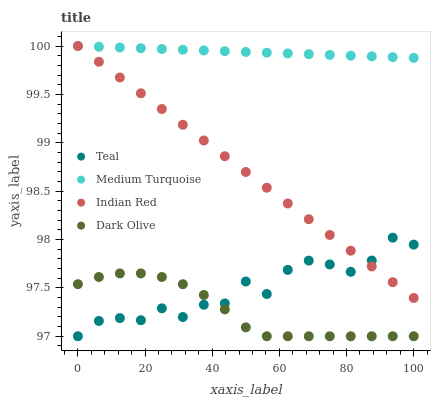Does Dark Olive have the minimum area under the curve?
Answer yes or no. Yes. Does Medium Turquoise have the maximum area under the curve?
Answer yes or no. Yes. Does Medium Turquoise have the minimum area under the curve?
Answer yes or no. No. Does Dark Olive have the maximum area under the curve?
Answer yes or no. No. Is Medium Turquoise the smoothest?
Answer yes or no. Yes. Is Teal the roughest?
Answer yes or no. Yes. Is Dark Olive the smoothest?
Answer yes or no. No. Is Dark Olive the roughest?
Answer yes or no. No. Does Dark Olive have the lowest value?
Answer yes or no. Yes. Does Medium Turquoise have the lowest value?
Answer yes or no. No. Does Medium Turquoise have the highest value?
Answer yes or no. Yes. Does Dark Olive have the highest value?
Answer yes or no. No. Is Teal less than Medium Turquoise?
Answer yes or no. Yes. Is Medium Turquoise greater than Teal?
Answer yes or no. Yes. Does Indian Red intersect Teal?
Answer yes or no. Yes. Is Indian Red less than Teal?
Answer yes or no. No. Is Indian Red greater than Teal?
Answer yes or no. No. Does Teal intersect Medium Turquoise?
Answer yes or no. No. 